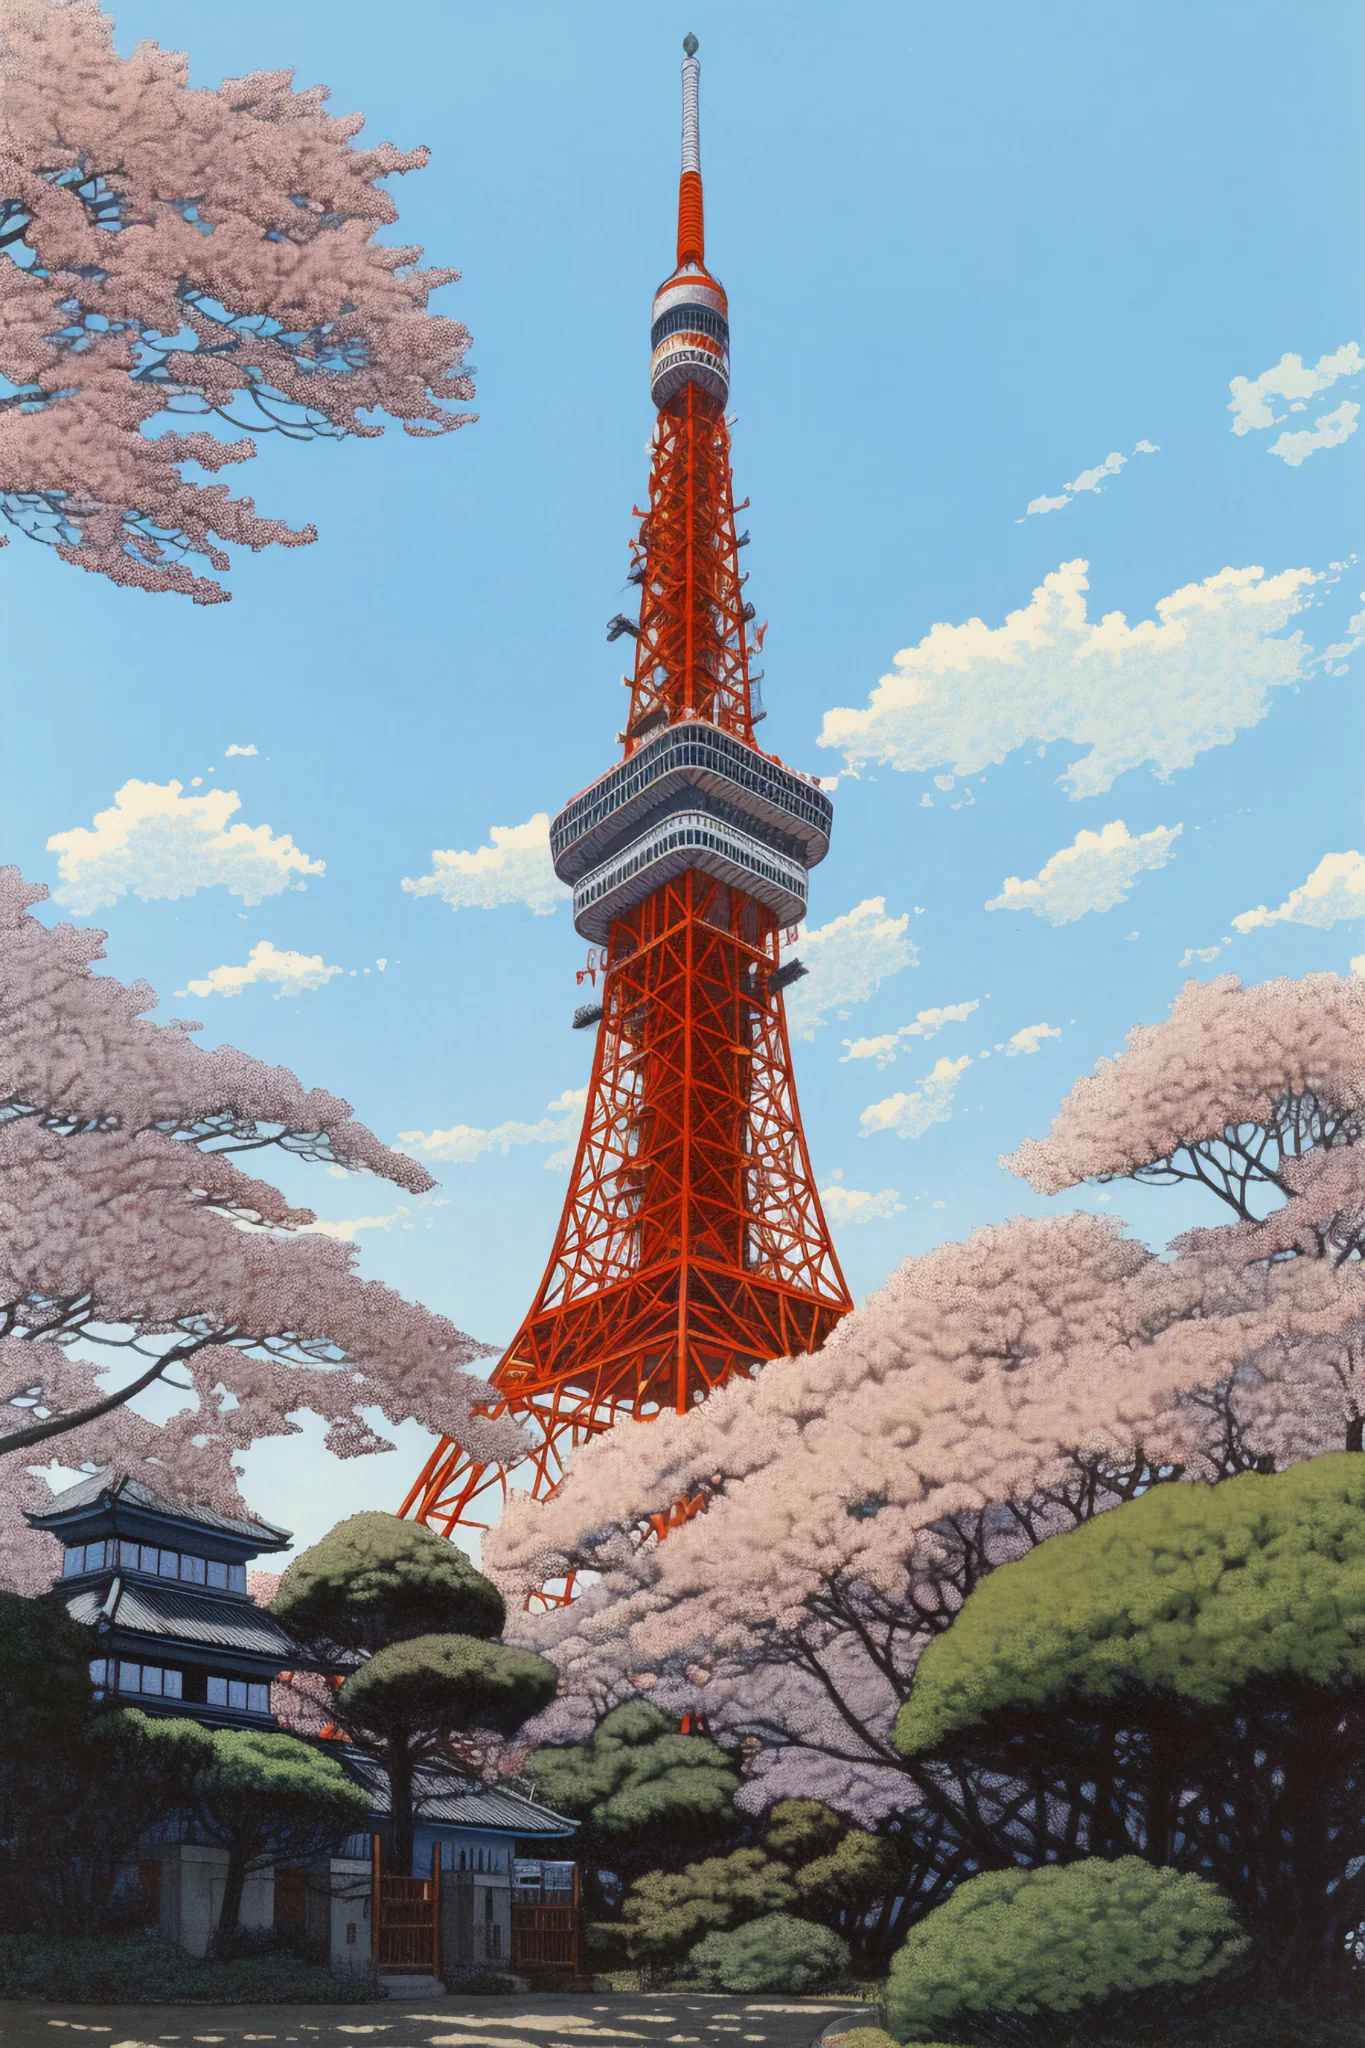What historical significance does Tokyo Tower hold in Japanese culture? Tokyo Tower is not only a celebrated landmark but also a symbol of Japan's post-war rebirth and rapid modernization in the 1950s. It was inspired by Paris's Eiffel Tower and has come to represent both technological progress and the enduring cultural heritage of Japan. Besides being a tourist attraction, it serves as a broadcasting antenna, illustrating the fusion of functional utility and aesthetic appeal in modern Japanese architecture. 